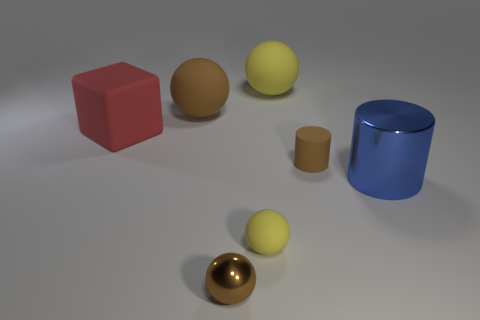Subtract all big yellow balls. How many balls are left? 3 Subtract 1 cubes. How many cubes are left? 0 Add 2 blue shiny things. How many objects exist? 9 Subtract all brown cylinders. How many cylinders are left? 1 Subtract 0 green cylinders. How many objects are left? 7 Subtract all cylinders. How many objects are left? 5 Subtract all blue cylinders. Subtract all purple blocks. How many cylinders are left? 1 Subtract all red spheres. How many yellow cubes are left? 0 Subtract all spheres. Subtract all big brown rubber objects. How many objects are left? 2 Add 1 rubber blocks. How many rubber blocks are left? 2 